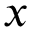<formula> <loc_0><loc_0><loc_500><loc_500>x</formula> 